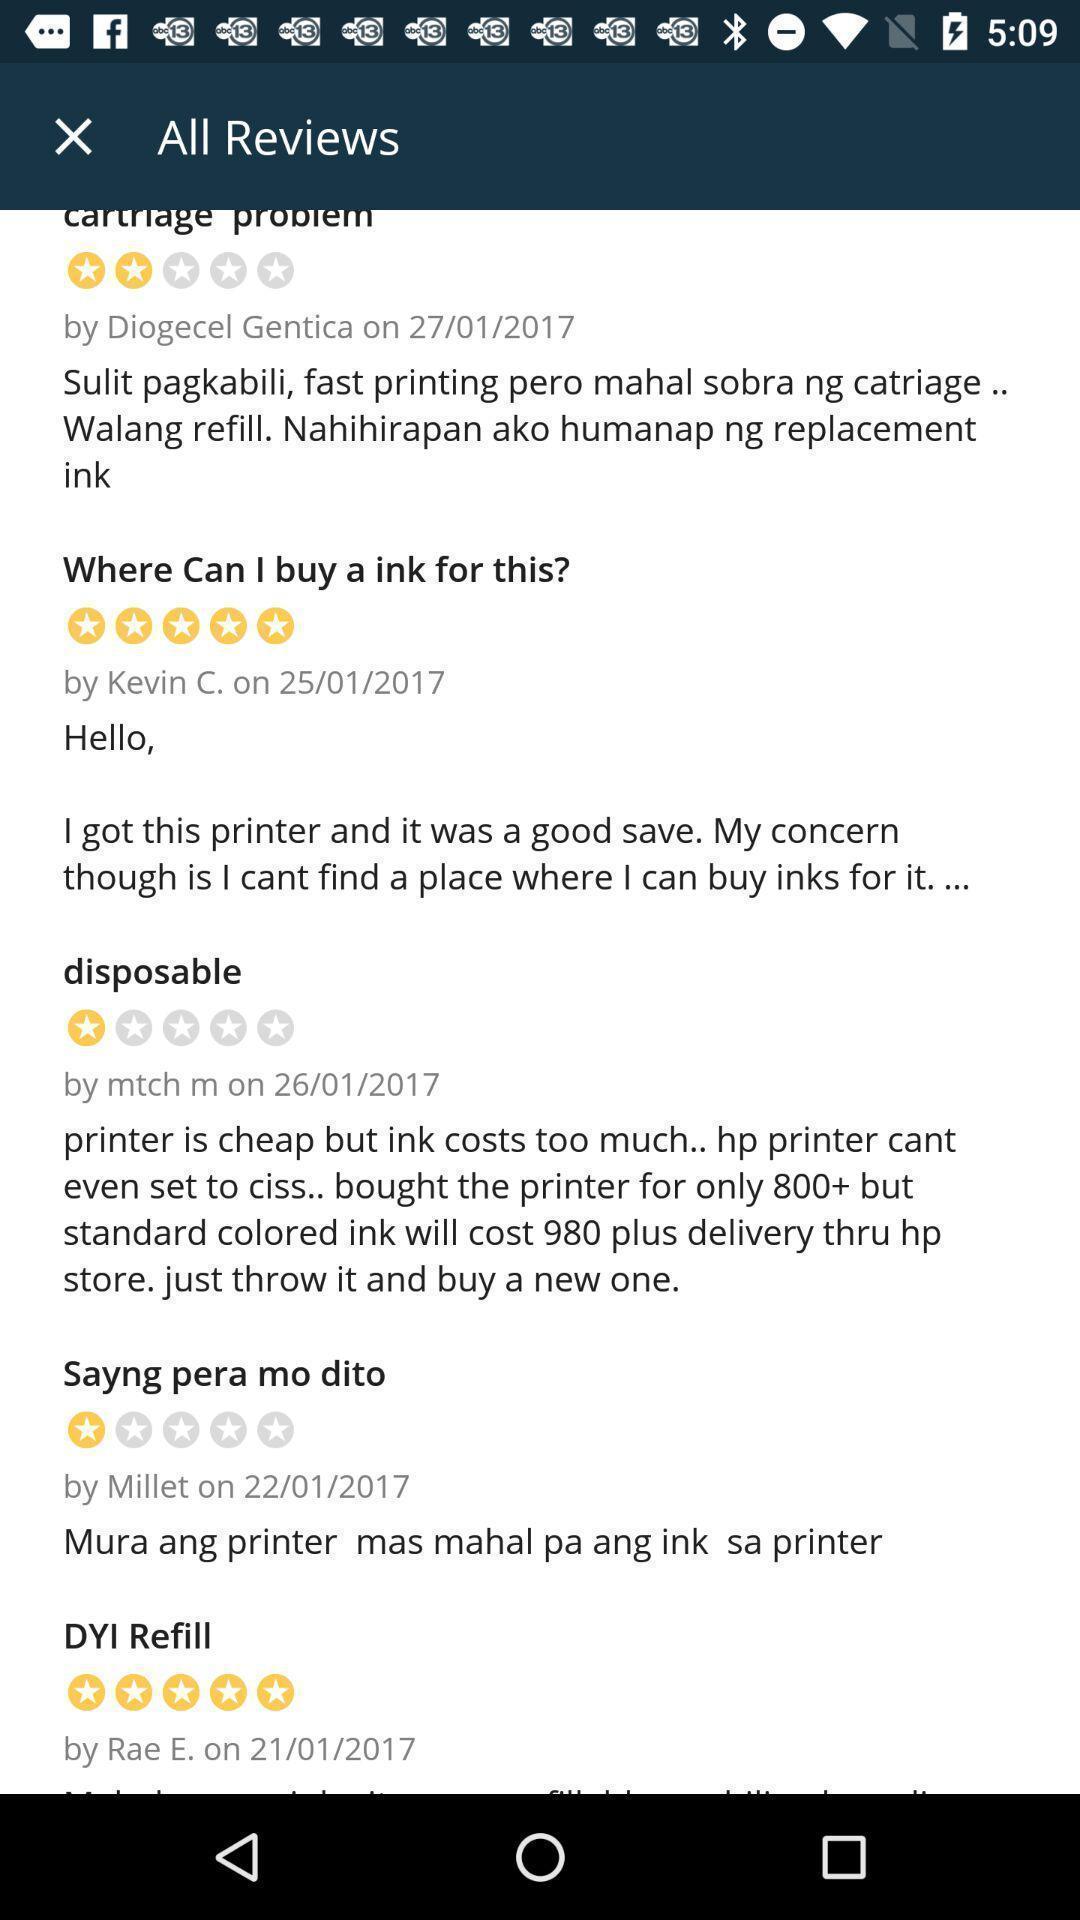Provide a description of this screenshot. Reviews of an online shopping app. 